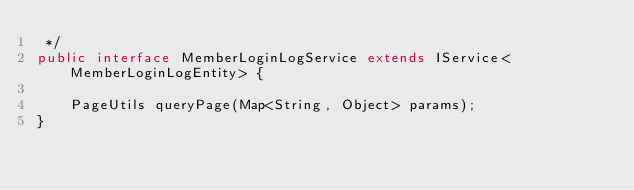Convert code to text. <code><loc_0><loc_0><loc_500><loc_500><_Java_> */
public interface MemberLoginLogService extends IService<MemberLoginLogEntity> {

    PageUtils queryPage(Map<String, Object> params);
}

</code> 